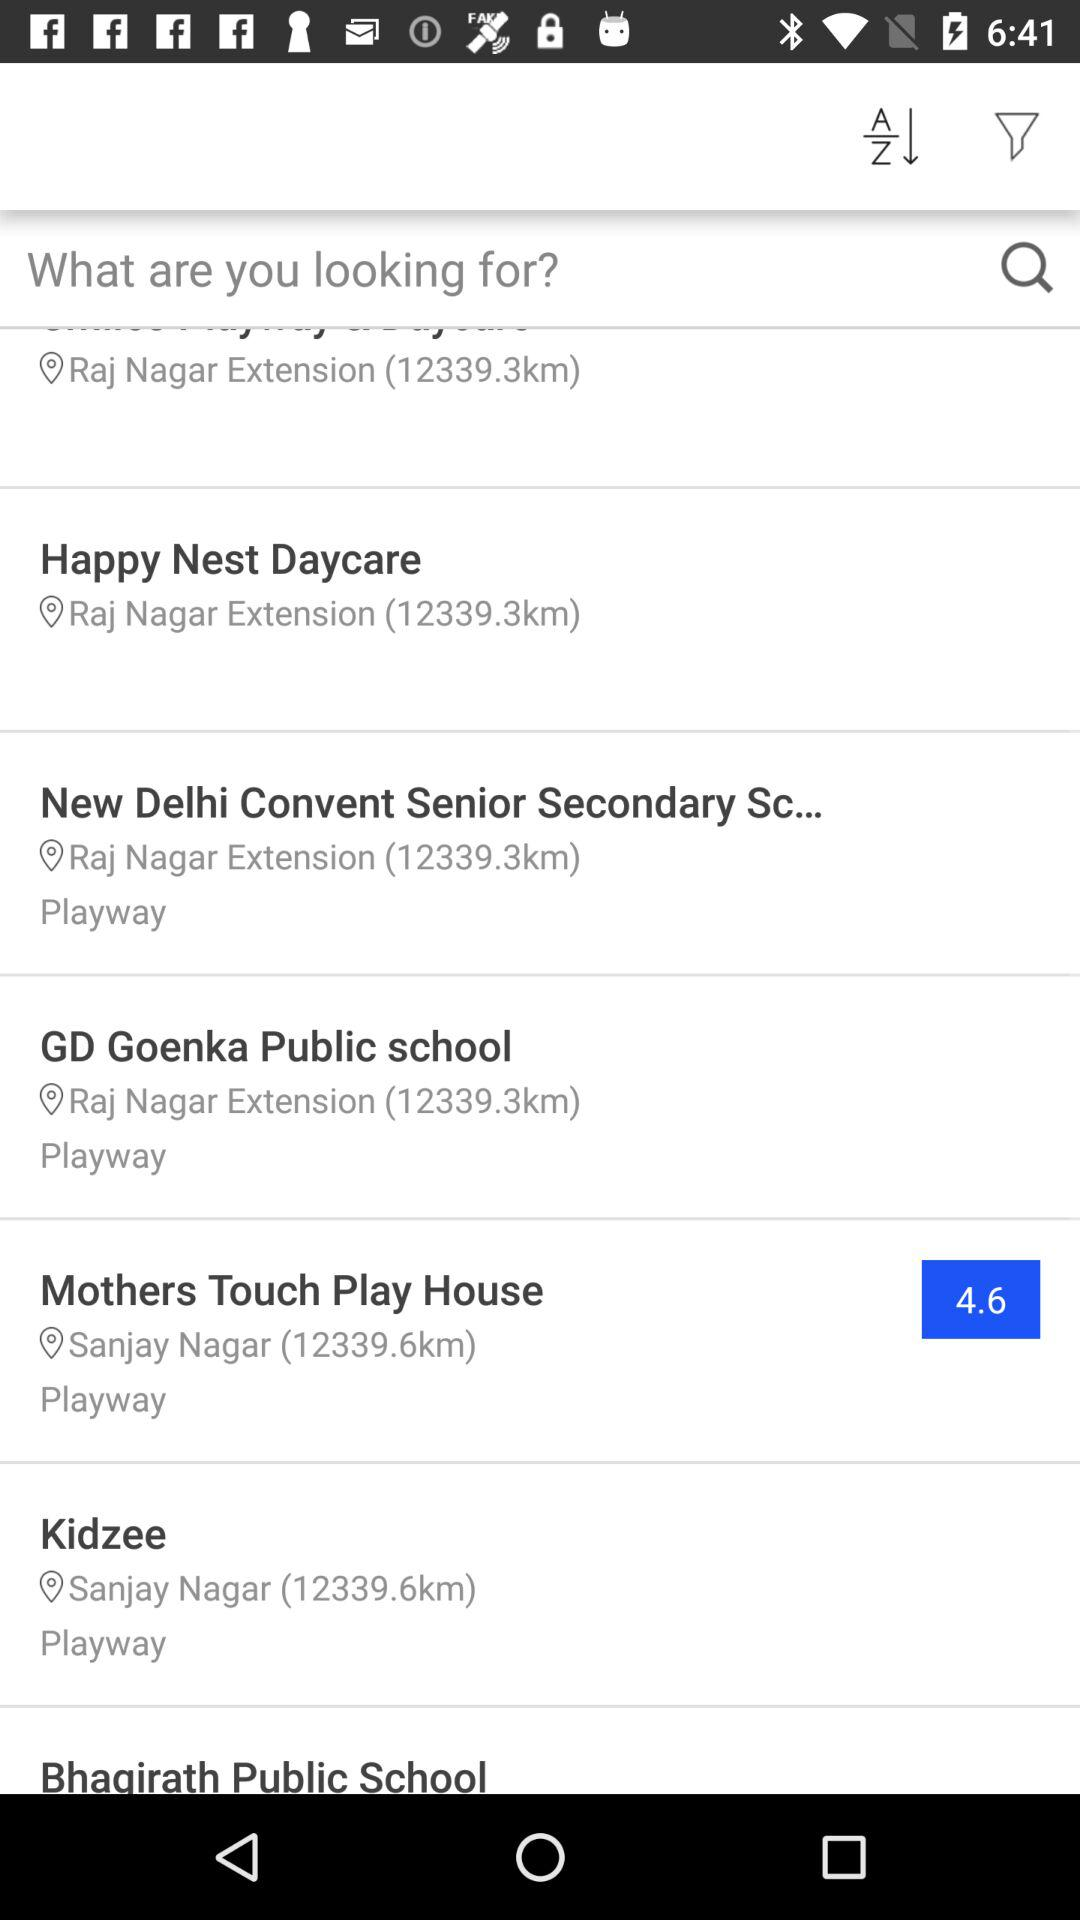What is the location of Happy Nest Daycare? The location of Happy Nest Daycare is "Raj Nagar Extension". 